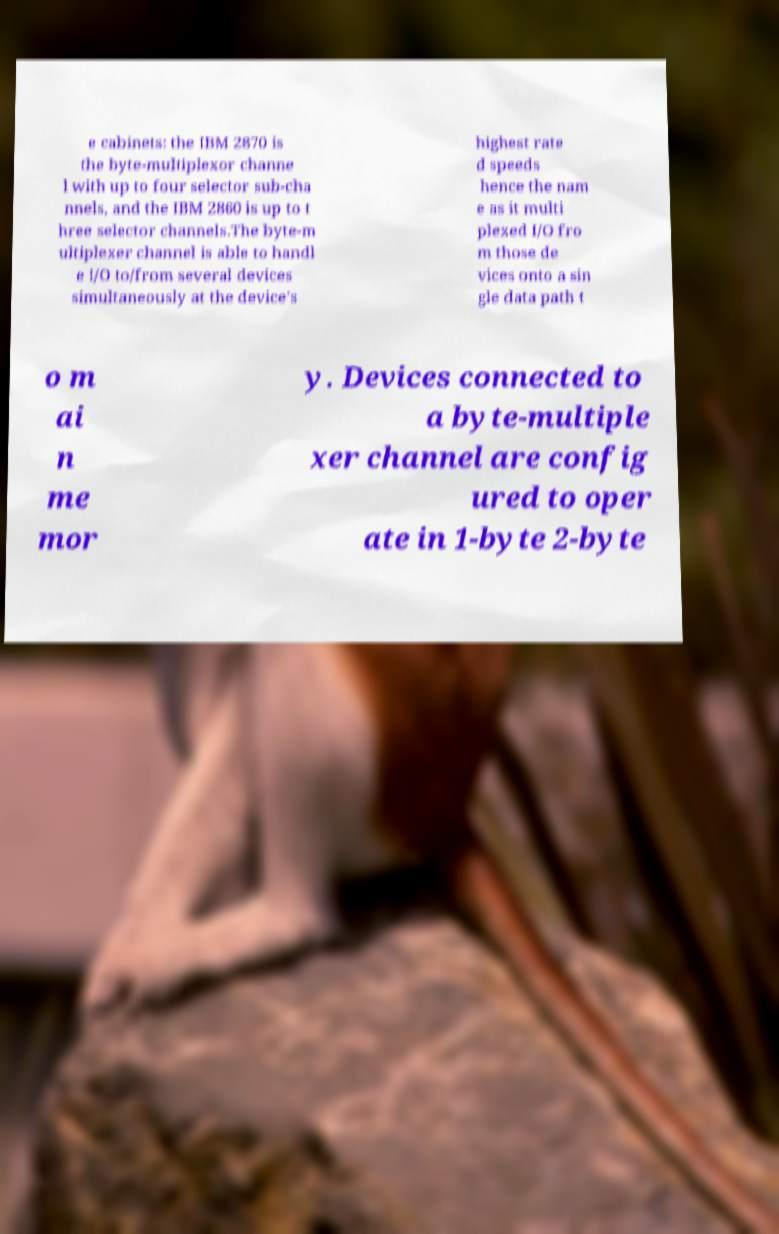Please identify and transcribe the text found in this image. e cabinets: the IBM 2870 is the byte-multiplexor channe l with up to four selector sub-cha nnels, and the IBM 2860 is up to t hree selector channels.The byte-m ultiplexer channel is able to handl e I/O to/from several devices simultaneously at the device's highest rate d speeds hence the nam e as it multi plexed I/O fro m those de vices onto a sin gle data path t o m ai n me mor y. Devices connected to a byte-multiple xer channel are config ured to oper ate in 1-byte 2-byte 